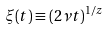<formula> <loc_0><loc_0><loc_500><loc_500>\xi ( t ) \equiv ( 2 \nu t ) ^ { 1 / z }</formula> 